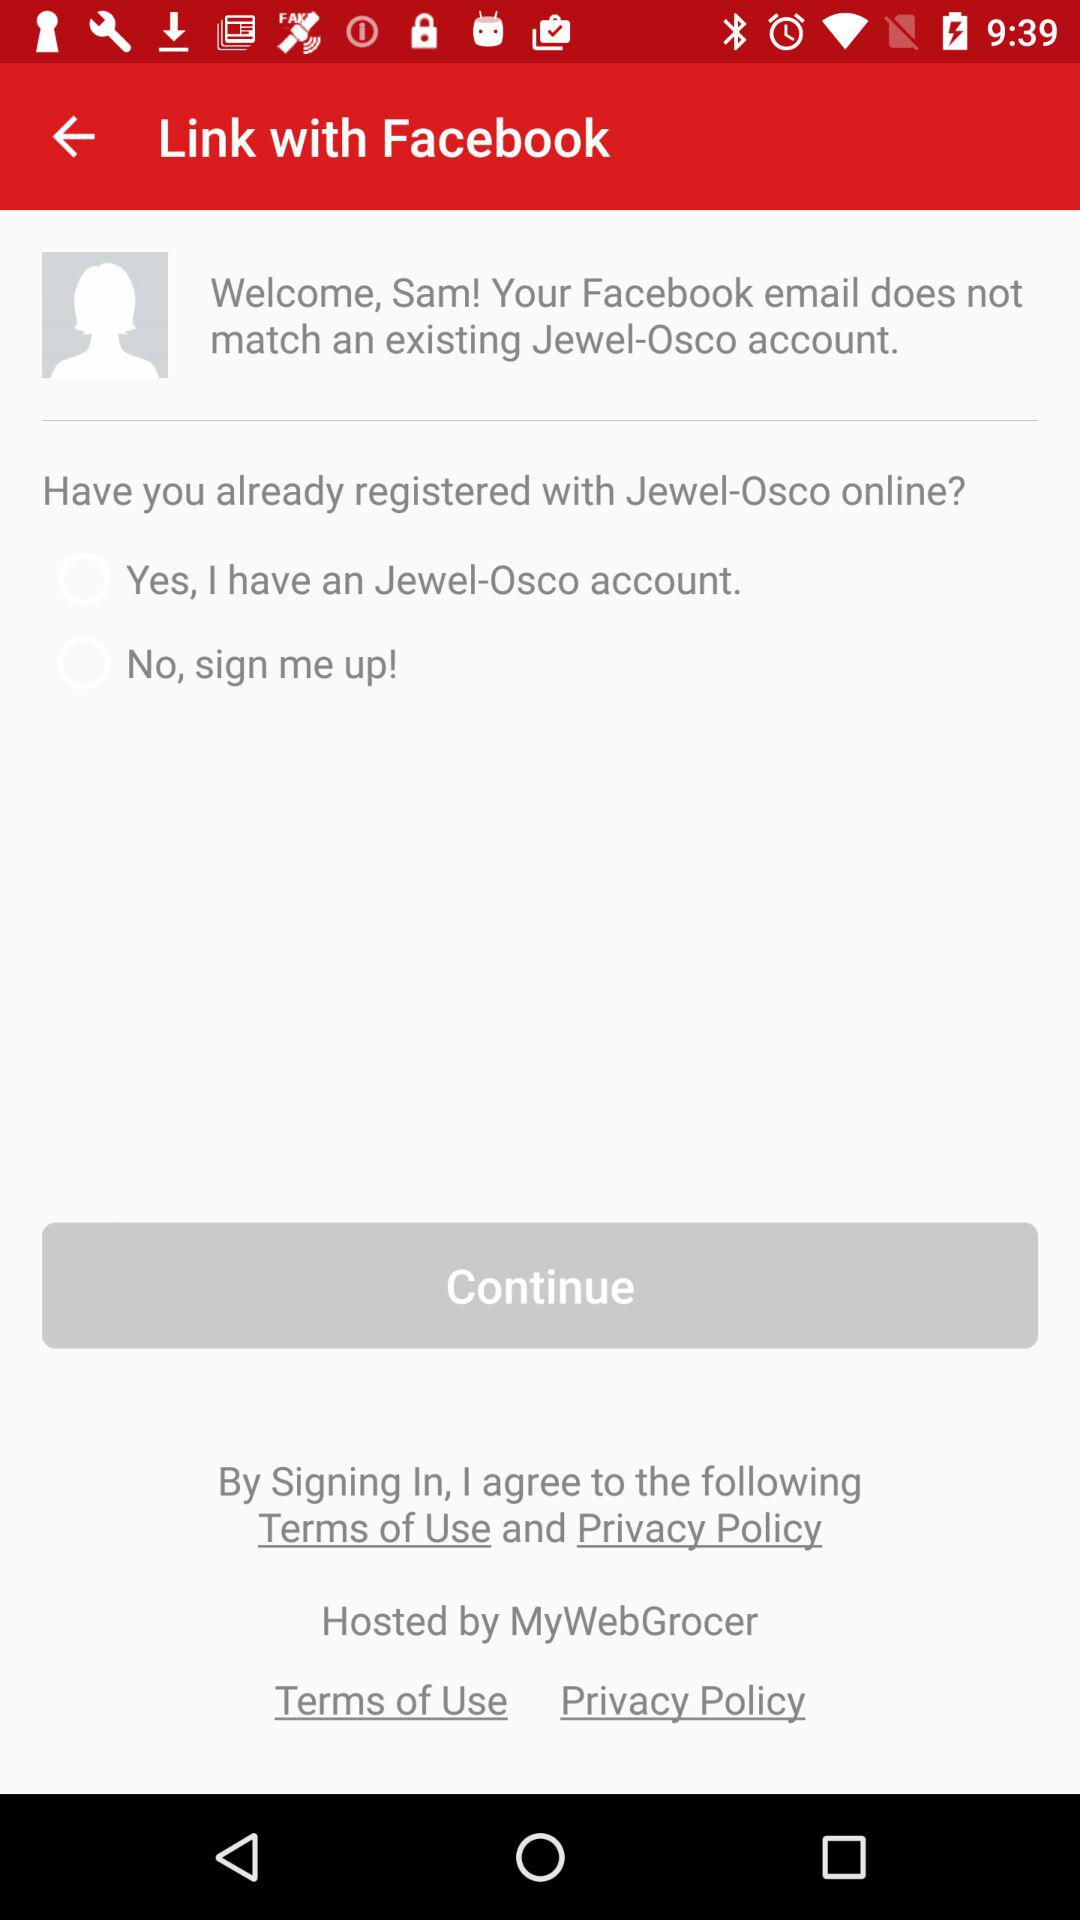What is the name of the user? The name of the user is Sam. 